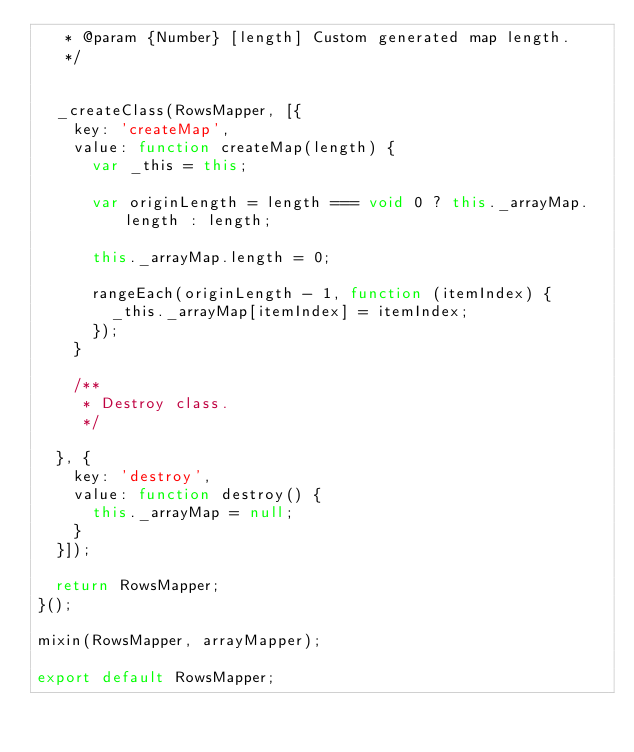Convert code to text. <code><loc_0><loc_0><loc_500><loc_500><_JavaScript_>   * @param {Number} [length] Custom generated map length.
   */


  _createClass(RowsMapper, [{
    key: 'createMap',
    value: function createMap(length) {
      var _this = this;

      var originLength = length === void 0 ? this._arrayMap.length : length;

      this._arrayMap.length = 0;

      rangeEach(originLength - 1, function (itemIndex) {
        _this._arrayMap[itemIndex] = itemIndex;
      });
    }

    /**
     * Destroy class.
     */

  }, {
    key: 'destroy',
    value: function destroy() {
      this._arrayMap = null;
    }
  }]);

  return RowsMapper;
}();

mixin(RowsMapper, arrayMapper);

export default RowsMapper;</code> 